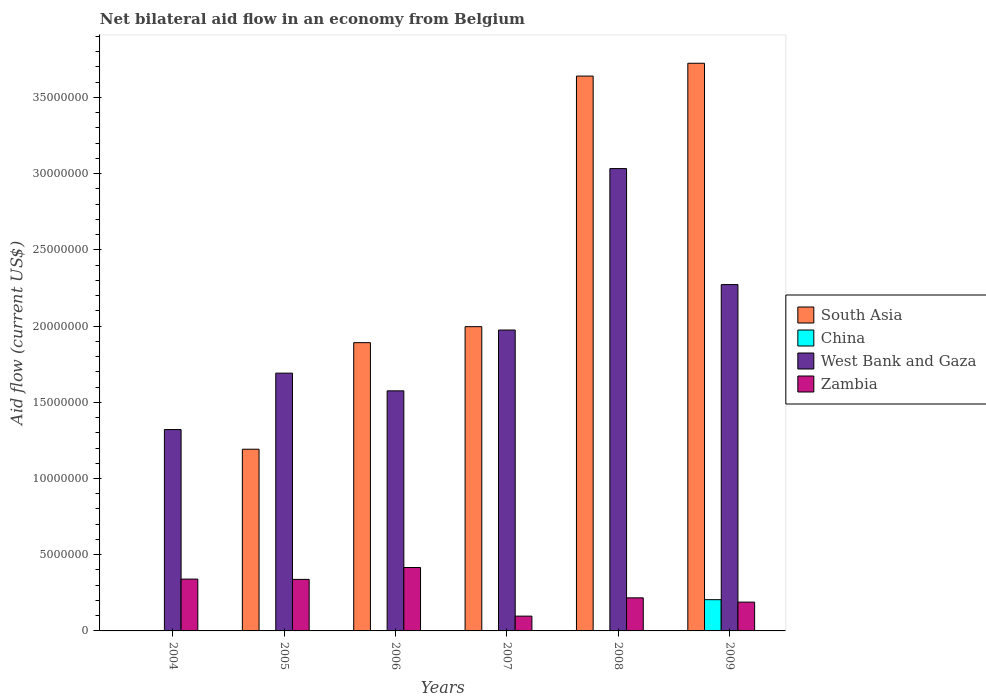In how many cases, is the number of bars for a given year not equal to the number of legend labels?
Give a very brief answer. 5. What is the net bilateral aid flow in West Bank and Gaza in 2005?
Offer a very short reply. 1.69e+07. Across all years, what is the maximum net bilateral aid flow in China?
Offer a very short reply. 2.05e+06. Across all years, what is the minimum net bilateral aid flow in West Bank and Gaza?
Offer a terse response. 1.32e+07. What is the total net bilateral aid flow in China in the graph?
Ensure brevity in your answer.  2.05e+06. What is the difference between the net bilateral aid flow in Zambia in 2006 and that in 2008?
Make the answer very short. 1.99e+06. What is the difference between the net bilateral aid flow in Zambia in 2005 and the net bilateral aid flow in South Asia in 2009?
Provide a succinct answer. -3.39e+07. What is the average net bilateral aid flow in South Asia per year?
Offer a terse response. 2.07e+07. In the year 2004, what is the difference between the net bilateral aid flow in West Bank and Gaza and net bilateral aid flow in Zambia?
Keep it short and to the point. 9.81e+06. What is the ratio of the net bilateral aid flow in West Bank and Gaza in 2004 to that in 2007?
Your answer should be compact. 0.67. What is the difference between the highest and the second highest net bilateral aid flow in West Bank and Gaza?
Ensure brevity in your answer.  7.61e+06. What is the difference between the highest and the lowest net bilateral aid flow in China?
Give a very brief answer. 2.05e+06. In how many years, is the net bilateral aid flow in South Asia greater than the average net bilateral aid flow in South Asia taken over all years?
Offer a terse response. 2. Is the sum of the net bilateral aid flow in West Bank and Gaza in 2006 and 2009 greater than the maximum net bilateral aid flow in South Asia across all years?
Keep it short and to the point. Yes. Is it the case that in every year, the sum of the net bilateral aid flow in China and net bilateral aid flow in West Bank and Gaza is greater than the sum of net bilateral aid flow in South Asia and net bilateral aid flow in Zambia?
Offer a terse response. Yes. Is it the case that in every year, the sum of the net bilateral aid flow in China and net bilateral aid flow in West Bank and Gaza is greater than the net bilateral aid flow in Zambia?
Give a very brief answer. Yes. How many bars are there?
Your answer should be very brief. 18. Are all the bars in the graph horizontal?
Offer a terse response. No. What is the difference between two consecutive major ticks on the Y-axis?
Provide a succinct answer. 5.00e+06. Are the values on the major ticks of Y-axis written in scientific E-notation?
Your response must be concise. No. Does the graph contain any zero values?
Offer a very short reply. Yes. How are the legend labels stacked?
Your response must be concise. Vertical. What is the title of the graph?
Your answer should be compact. Net bilateral aid flow in an economy from Belgium. Does "Turkey" appear as one of the legend labels in the graph?
Your response must be concise. No. What is the Aid flow (current US$) of West Bank and Gaza in 2004?
Provide a succinct answer. 1.32e+07. What is the Aid flow (current US$) of Zambia in 2004?
Give a very brief answer. 3.40e+06. What is the Aid flow (current US$) in South Asia in 2005?
Keep it short and to the point. 1.19e+07. What is the Aid flow (current US$) of West Bank and Gaza in 2005?
Your response must be concise. 1.69e+07. What is the Aid flow (current US$) in Zambia in 2005?
Provide a succinct answer. 3.38e+06. What is the Aid flow (current US$) of South Asia in 2006?
Provide a succinct answer. 1.89e+07. What is the Aid flow (current US$) of West Bank and Gaza in 2006?
Ensure brevity in your answer.  1.58e+07. What is the Aid flow (current US$) in Zambia in 2006?
Your answer should be compact. 4.16e+06. What is the Aid flow (current US$) in South Asia in 2007?
Your answer should be compact. 2.00e+07. What is the Aid flow (current US$) of West Bank and Gaza in 2007?
Offer a very short reply. 1.97e+07. What is the Aid flow (current US$) in Zambia in 2007?
Make the answer very short. 9.70e+05. What is the Aid flow (current US$) in South Asia in 2008?
Give a very brief answer. 3.64e+07. What is the Aid flow (current US$) of West Bank and Gaza in 2008?
Keep it short and to the point. 3.03e+07. What is the Aid flow (current US$) of Zambia in 2008?
Your answer should be very brief. 2.17e+06. What is the Aid flow (current US$) in South Asia in 2009?
Provide a short and direct response. 3.72e+07. What is the Aid flow (current US$) of China in 2009?
Your response must be concise. 2.05e+06. What is the Aid flow (current US$) of West Bank and Gaza in 2009?
Offer a very short reply. 2.27e+07. What is the Aid flow (current US$) of Zambia in 2009?
Ensure brevity in your answer.  1.89e+06. Across all years, what is the maximum Aid flow (current US$) in South Asia?
Your answer should be compact. 3.72e+07. Across all years, what is the maximum Aid flow (current US$) in China?
Your response must be concise. 2.05e+06. Across all years, what is the maximum Aid flow (current US$) in West Bank and Gaza?
Your answer should be very brief. 3.03e+07. Across all years, what is the maximum Aid flow (current US$) of Zambia?
Offer a very short reply. 4.16e+06. Across all years, what is the minimum Aid flow (current US$) of China?
Provide a succinct answer. 0. Across all years, what is the minimum Aid flow (current US$) in West Bank and Gaza?
Provide a short and direct response. 1.32e+07. Across all years, what is the minimum Aid flow (current US$) in Zambia?
Provide a short and direct response. 9.70e+05. What is the total Aid flow (current US$) in South Asia in the graph?
Keep it short and to the point. 1.24e+08. What is the total Aid flow (current US$) of China in the graph?
Offer a very short reply. 2.05e+06. What is the total Aid flow (current US$) in West Bank and Gaza in the graph?
Keep it short and to the point. 1.19e+08. What is the total Aid flow (current US$) in Zambia in the graph?
Ensure brevity in your answer.  1.60e+07. What is the difference between the Aid flow (current US$) of West Bank and Gaza in 2004 and that in 2005?
Your answer should be very brief. -3.70e+06. What is the difference between the Aid flow (current US$) of West Bank and Gaza in 2004 and that in 2006?
Offer a very short reply. -2.54e+06. What is the difference between the Aid flow (current US$) in Zambia in 2004 and that in 2006?
Provide a succinct answer. -7.60e+05. What is the difference between the Aid flow (current US$) of West Bank and Gaza in 2004 and that in 2007?
Ensure brevity in your answer.  -6.53e+06. What is the difference between the Aid flow (current US$) of Zambia in 2004 and that in 2007?
Provide a succinct answer. 2.43e+06. What is the difference between the Aid flow (current US$) in West Bank and Gaza in 2004 and that in 2008?
Provide a short and direct response. -1.71e+07. What is the difference between the Aid flow (current US$) in Zambia in 2004 and that in 2008?
Provide a short and direct response. 1.23e+06. What is the difference between the Aid flow (current US$) in West Bank and Gaza in 2004 and that in 2009?
Offer a terse response. -9.51e+06. What is the difference between the Aid flow (current US$) of Zambia in 2004 and that in 2009?
Offer a terse response. 1.51e+06. What is the difference between the Aid flow (current US$) of South Asia in 2005 and that in 2006?
Ensure brevity in your answer.  -6.99e+06. What is the difference between the Aid flow (current US$) of West Bank and Gaza in 2005 and that in 2006?
Your response must be concise. 1.16e+06. What is the difference between the Aid flow (current US$) of Zambia in 2005 and that in 2006?
Offer a very short reply. -7.80e+05. What is the difference between the Aid flow (current US$) of South Asia in 2005 and that in 2007?
Give a very brief answer. -8.04e+06. What is the difference between the Aid flow (current US$) in West Bank and Gaza in 2005 and that in 2007?
Provide a succinct answer. -2.83e+06. What is the difference between the Aid flow (current US$) in Zambia in 2005 and that in 2007?
Give a very brief answer. 2.41e+06. What is the difference between the Aid flow (current US$) in South Asia in 2005 and that in 2008?
Your response must be concise. -2.45e+07. What is the difference between the Aid flow (current US$) in West Bank and Gaza in 2005 and that in 2008?
Ensure brevity in your answer.  -1.34e+07. What is the difference between the Aid flow (current US$) in Zambia in 2005 and that in 2008?
Offer a terse response. 1.21e+06. What is the difference between the Aid flow (current US$) in South Asia in 2005 and that in 2009?
Provide a succinct answer. -2.53e+07. What is the difference between the Aid flow (current US$) of West Bank and Gaza in 2005 and that in 2009?
Provide a short and direct response. -5.81e+06. What is the difference between the Aid flow (current US$) in Zambia in 2005 and that in 2009?
Make the answer very short. 1.49e+06. What is the difference between the Aid flow (current US$) of South Asia in 2006 and that in 2007?
Ensure brevity in your answer.  -1.05e+06. What is the difference between the Aid flow (current US$) in West Bank and Gaza in 2006 and that in 2007?
Offer a terse response. -3.99e+06. What is the difference between the Aid flow (current US$) of Zambia in 2006 and that in 2007?
Your answer should be very brief. 3.19e+06. What is the difference between the Aid flow (current US$) in South Asia in 2006 and that in 2008?
Your answer should be compact. -1.75e+07. What is the difference between the Aid flow (current US$) of West Bank and Gaza in 2006 and that in 2008?
Keep it short and to the point. -1.46e+07. What is the difference between the Aid flow (current US$) in Zambia in 2006 and that in 2008?
Make the answer very short. 1.99e+06. What is the difference between the Aid flow (current US$) of South Asia in 2006 and that in 2009?
Provide a succinct answer. -1.83e+07. What is the difference between the Aid flow (current US$) in West Bank and Gaza in 2006 and that in 2009?
Keep it short and to the point. -6.97e+06. What is the difference between the Aid flow (current US$) of Zambia in 2006 and that in 2009?
Make the answer very short. 2.27e+06. What is the difference between the Aid flow (current US$) of South Asia in 2007 and that in 2008?
Keep it short and to the point. -1.64e+07. What is the difference between the Aid flow (current US$) of West Bank and Gaza in 2007 and that in 2008?
Provide a succinct answer. -1.06e+07. What is the difference between the Aid flow (current US$) in Zambia in 2007 and that in 2008?
Keep it short and to the point. -1.20e+06. What is the difference between the Aid flow (current US$) of South Asia in 2007 and that in 2009?
Offer a terse response. -1.73e+07. What is the difference between the Aid flow (current US$) in West Bank and Gaza in 2007 and that in 2009?
Give a very brief answer. -2.98e+06. What is the difference between the Aid flow (current US$) in Zambia in 2007 and that in 2009?
Keep it short and to the point. -9.20e+05. What is the difference between the Aid flow (current US$) in South Asia in 2008 and that in 2009?
Offer a very short reply. -8.40e+05. What is the difference between the Aid flow (current US$) in West Bank and Gaza in 2008 and that in 2009?
Keep it short and to the point. 7.61e+06. What is the difference between the Aid flow (current US$) in Zambia in 2008 and that in 2009?
Offer a very short reply. 2.80e+05. What is the difference between the Aid flow (current US$) of West Bank and Gaza in 2004 and the Aid flow (current US$) of Zambia in 2005?
Provide a succinct answer. 9.83e+06. What is the difference between the Aid flow (current US$) in West Bank and Gaza in 2004 and the Aid flow (current US$) in Zambia in 2006?
Give a very brief answer. 9.05e+06. What is the difference between the Aid flow (current US$) of West Bank and Gaza in 2004 and the Aid flow (current US$) of Zambia in 2007?
Your answer should be compact. 1.22e+07. What is the difference between the Aid flow (current US$) in West Bank and Gaza in 2004 and the Aid flow (current US$) in Zambia in 2008?
Make the answer very short. 1.10e+07. What is the difference between the Aid flow (current US$) in West Bank and Gaza in 2004 and the Aid flow (current US$) in Zambia in 2009?
Your answer should be very brief. 1.13e+07. What is the difference between the Aid flow (current US$) in South Asia in 2005 and the Aid flow (current US$) in West Bank and Gaza in 2006?
Your answer should be very brief. -3.83e+06. What is the difference between the Aid flow (current US$) of South Asia in 2005 and the Aid flow (current US$) of Zambia in 2006?
Make the answer very short. 7.76e+06. What is the difference between the Aid flow (current US$) of West Bank and Gaza in 2005 and the Aid flow (current US$) of Zambia in 2006?
Offer a very short reply. 1.28e+07. What is the difference between the Aid flow (current US$) in South Asia in 2005 and the Aid flow (current US$) in West Bank and Gaza in 2007?
Offer a very short reply. -7.82e+06. What is the difference between the Aid flow (current US$) in South Asia in 2005 and the Aid flow (current US$) in Zambia in 2007?
Your answer should be compact. 1.10e+07. What is the difference between the Aid flow (current US$) in West Bank and Gaza in 2005 and the Aid flow (current US$) in Zambia in 2007?
Give a very brief answer. 1.59e+07. What is the difference between the Aid flow (current US$) of South Asia in 2005 and the Aid flow (current US$) of West Bank and Gaza in 2008?
Your response must be concise. -1.84e+07. What is the difference between the Aid flow (current US$) in South Asia in 2005 and the Aid flow (current US$) in Zambia in 2008?
Your answer should be very brief. 9.75e+06. What is the difference between the Aid flow (current US$) in West Bank and Gaza in 2005 and the Aid flow (current US$) in Zambia in 2008?
Your answer should be very brief. 1.47e+07. What is the difference between the Aid flow (current US$) in South Asia in 2005 and the Aid flow (current US$) in China in 2009?
Provide a succinct answer. 9.87e+06. What is the difference between the Aid flow (current US$) of South Asia in 2005 and the Aid flow (current US$) of West Bank and Gaza in 2009?
Provide a succinct answer. -1.08e+07. What is the difference between the Aid flow (current US$) in South Asia in 2005 and the Aid flow (current US$) in Zambia in 2009?
Offer a very short reply. 1.00e+07. What is the difference between the Aid flow (current US$) in West Bank and Gaza in 2005 and the Aid flow (current US$) in Zambia in 2009?
Your answer should be compact. 1.50e+07. What is the difference between the Aid flow (current US$) in South Asia in 2006 and the Aid flow (current US$) in West Bank and Gaza in 2007?
Make the answer very short. -8.30e+05. What is the difference between the Aid flow (current US$) of South Asia in 2006 and the Aid flow (current US$) of Zambia in 2007?
Your answer should be very brief. 1.79e+07. What is the difference between the Aid flow (current US$) of West Bank and Gaza in 2006 and the Aid flow (current US$) of Zambia in 2007?
Provide a short and direct response. 1.48e+07. What is the difference between the Aid flow (current US$) in South Asia in 2006 and the Aid flow (current US$) in West Bank and Gaza in 2008?
Your response must be concise. -1.14e+07. What is the difference between the Aid flow (current US$) of South Asia in 2006 and the Aid flow (current US$) of Zambia in 2008?
Your answer should be compact. 1.67e+07. What is the difference between the Aid flow (current US$) in West Bank and Gaza in 2006 and the Aid flow (current US$) in Zambia in 2008?
Your response must be concise. 1.36e+07. What is the difference between the Aid flow (current US$) of South Asia in 2006 and the Aid flow (current US$) of China in 2009?
Offer a terse response. 1.69e+07. What is the difference between the Aid flow (current US$) of South Asia in 2006 and the Aid flow (current US$) of West Bank and Gaza in 2009?
Your response must be concise. -3.81e+06. What is the difference between the Aid flow (current US$) in South Asia in 2006 and the Aid flow (current US$) in Zambia in 2009?
Make the answer very short. 1.70e+07. What is the difference between the Aid flow (current US$) of West Bank and Gaza in 2006 and the Aid flow (current US$) of Zambia in 2009?
Your response must be concise. 1.39e+07. What is the difference between the Aid flow (current US$) in South Asia in 2007 and the Aid flow (current US$) in West Bank and Gaza in 2008?
Offer a terse response. -1.04e+07. What is the difference between the Aid flow (current US$) of South Asia in 2007 and the Aid flow (current US$) of Zambia in 2008?
Your answer should be compact. 1.78e+07. What is the difference between the Aid flow (current US$) of West Bank and Gaza in 2007 and the Aid flow (current US$) of Zambia in 2008?
Ensure brevity in your answer.  1.76e+07. What is the difference between the Aid flow (current US$) of South Asia in 2007 and the Aid flow (current US$) of China in 2009?
Provide a succinct answer. 1.79e+07. What is the difference between the Aid flow (current US$) in South Asia in 2007 and the Aid flow (current US$) in West Bank and Gaza in 2009?
Offer a very short reply. -2.76e+06. What is the difference between the Aid flow (current US$) in South Asia in 2007 and the Aid flow (current US$) in Zambia in 2009?
Offer a terse response. 1.81e+07. What is the difference between the Aid flow (current US$) of West Bank and Gaza in 2007 and the Aid flow (current US$) of Zambia in 2009?
Offer a very short reply. 1.78e+07. What is the difference between the Aid flow (current US$) of South Asia in 2008 and the Aid flow (current US$) of China in 2009?
Your answer should be compact. 3.44e+07. What is the difference between the Aid flow (current US$) in South Asia in 2008 and the Aid flow (current US$) in West Bank and Gaza in 2009?
Your response must be concise. 1.37e+07. What is the difference between the Aid flow (current US$) of South Asia in 2008 and the Aid flow (current US$) of Zambia in 2009?
Give a very brief answer. 3.45e+07. What is the difference between the Aid flow (current US$) in West Bank and Gaza in 2008 and the Aid flow (current US$) in Zambia in 2009?
Offer a terse response. 2.84e+07. What is the average Aid flow (current US$) in South Asia per year?
Offer a terse response. 2.07e+07. What is the average Aid flow (current US$) of China per year?
Your response must be concise. 3.42e+05. What is the average Aid flow (current US$) in West Bank and Gaza per year?
Offer a terse response. 1.98e+07. What is the average Aid flow (current US$) in Zambia per year?
Your answer should be very brief. 2.66e+06. In the year 2004, what is the difference between the Aid flow (current US$) of West Bank and Gaza and Aid flow (current US$) of Zambia?
Your answer should be very brief. 9.81e+06. In the year 2005, what is the difference between the Aid flow (current US$) of South Asia and Aid flow (current US$) of West Bank and Gaza?
Provide a succinct answer. -4.99e+06. In the year 2005, what is the difference between the Aid flow (current US$) in South Asia and Aid flow (current US$) in Zambia?
Keep it short and to the point. 8.54e+06. In the year 2005, what is the difference between the Aid flow (current US$) in West Bank and Gaza and Aid flow (current US$) in Zambia?
Offer a terse response. 1.35e+07. In the year 2006, what is the difference between the Aid flow (current US$) in South Asia and Aid flow (current US$) in West Bank and Gaza?
Ensure brevity in your answer.  3.16e+06. In the year 2006, what is the difference between the Aid flow (current US$) of South Asia and Aid flow (current US$) of Zambia?
Your answer should be compact. 1.48e+07. In the year 2006, what is the difference between the Aid flow (current US$) in West Bank and Gaza and Aid flow (current US$) in Zambia?
Provide a succinct answer. 1.16e+07. In the year 2007, what is the difference between the Aid flow (current US$) in South Asia and Aid flow (current US$) in Zambia?
Give a very brief answer. 1.90e+07. In the year 2007, what is the difference between the Aid flow (current US$) of West Bank and Gaza and Aid flow (current US$) of Zambia?
Your answer should be compact. 1.88e+07. In the year 2008, what is the difference between the Aid flow (current US$) of South Asia and Aid flow (current US$) of West Bank and Gaza?
Offer a terse response. 6.07e+06. In the year 2008, what is the difference between the Aid flow (current US$) in South Asia and Aid flow (current US$) in Zambia?
Your response must be concise. 3.42e+07. In the year 2008, what is the difference between the Aid flow (current US$) of West Bank and Gaza and Aid flow (current US$) of Zambia?
Keep it short and to the point. 2.82e+07. In the year 2009, what is the difference between the Aid flow (current US$) in South Asia and Aid flow (current US$) in China?
Keep it short and to the point. 3.52e+07. In the year 2009, what is the difference between the Aid flow (current US$) in South Asia and Aid flow (current US$) in West Bank and Gaza?
Keep it short and to the point. 1.45e+07. In the year 2009, what is the difference between the Aid flow (current US$) in South Asia and Aid flow (current US$) in Zambia?
Provide a short and direct response. 3.54e+07. In the year 2009, what is the difference between the Aid flow (current US$) in China and Aid flow (current US$) in West Bank and Gaza?
Your answer should be very brief. -2.07e+07. In the year 2009, what is the difference between the Aid flow (current US$) of China and Aid flow (current US$) of Zambia?
Your response must be concise. 1.60e+05. In the year 2009, what is the difference between the Aid flow (current US$) in West Bank and Gaza and Aid flow (current US$) in Zambia?
Your answer should be compact. 2.08e+07. What is the ratio of the Aid flow (current US$) in West Bank and Gaza in 2004 to that in 2005?
Provide a short and direct response. 0.78. What is the ratio of the Aid flow (current US$) in Zambia in 2004 to that in 2005?
Your answer should be compact. 1.01. What is the ratio of the Aid flow (current US$) of West Bank and Gaza in 2004 to that in 2006?
Your response must be concise. 0.84. What is the ratio of the Aid flow (current US$) of Zambia in 2004 to that in 2006?
Your response must be concise. 0.82. What is the ratio of the Aid flow (current US$) in West Bank and Gaza in 2004 to that in 2007?
Keep it short and to the point. 0.67. What is the ratio of the Aid flow (current US$) of Zambia in 2004 to that in 2007?
Keep it short and to the point. 3.51. What is the ratio of the Aid flow (current US$) in West Bank and Gaza in 2004 to that in 2008?
Provide a short and direct response. 0.44. What is the ratio of the Aid flow (current US$) of Zambia in 2004 to that in 2008?
Keep it short and to the point. 1.57. What is the ratio of the Aid flow (current US$) of West Bank and Gaza in 2004 to that in 2009?
Provide a short and direct response. 0.58. What is the ratio of the Aid flow (current US$) of Zambia in 2004 to that in 2009?
Make the answer very short. 1.8. What is the ratio of the Aid flow (current US$) in South Asia in 2005 to that in 2006?
Make the answer very short. 0.63. What is the ratio of the Aid flow (current US$) of West Bank and Gaza in 2005 to that in 2006?
Make the answer very short. 1.07. What is the ratio of the Aid flow (current US$) of Zambia in 2005 to that in 2006?
Offer a very short reply. 0.81. What is the ratio of the Aid flow (current US$) of South Asia in 2005 to that in 2007?
Give a very brief answer. 0.6. What is the ratio of the Aid flow (current US$) in West Bank and Gaza in 2005 to that in 2007?
Your response must be concise. 0.86. What is the ratio of the Aid flow (current US$) of Zambia in 2005 to that in 2007?
Provide a short and direct response. 3.48. What is the ratio of the Aid flow (current US$) of South Asia in 2005 to that in 2008?
Make the answer very short. 0.33. What is the ratio of the Aid flow (current US$) of West Bank and Gaza in 2005 to that in 2008?
Ensure brevity in your answer.  0.56. What is the ratio of the Aid flow (current US$) of Zambia in 2005 to that in 2008?
Give a very brief answer. 1.56. What is the ratio of the Aid flow (current US$) in South Asia in 2005 to that in 2009?
Keep it short and to the point. 0.32. What is the ratio of the Aid flow (current US$) in West Bank and Gaza in 2005 to that in 2009?
Your answer should be very brief. 0.74. What is the ratio of the Aid flow (current US$) in Zambia in 2005 to that in 2009?
Your answer should be compact. 1.79. What is the ratio of the Aid flow (current US$) of South Asia in 2006 to that in 2007?
Your response must be concise. 0.95. What is the ratio of the Aid flow (current US$) of West Bank and Gaza in 2006 to that in 2007?
Your answer should be compact. 0.8. What is the ratio of the Aid flow (current US$) of Zambia in 2006 to that in 2007?
Keep it short and to the point. 4.29. What is the ratio of the Aid flow (current US$) of South Asia in 2006 to that in 2008?
Provide a succinct answer. 0.52. What is the ratio of the Aid flow (current US$) in West Bank and Gaza in 2006 to that in 2008?
Your answer should be compact. 0.52. What is the ratio of the Aid flow (current US$) in Zambia in 2006 to that in 2008?
Your response must be concise. 1.92. What is the ratio of the Aid flow (current US$) of South Asia in 2006 to that in 2009?
Offer a terse response. 0.51. What is the ratio of the Aid flow (current US$) in West Bank and Gaza in 2006 to that in 2009?
Ensure brevity in your answer.  0.69. What is the ratio of the Aid flow (current US$) of Zambia in 2006 to that in 2009?
Make the answer very short. 2.2. What is the ratio of the Aid flow (current US$) of South Asia in 2007 to that in 2008?
Make the answer very short. 0.55. What is the ratio of the Aid flow (current US$) in West Bank and Gaza in 2007 to that in 2008?
Your answer should be compact. 0.65. What is the ratio of the Aid flow (current US$) of Zambia in 2007 to that in 2008?
Keep it short and to the point. 0.45. What is the ratio of the Aid flow (current US$) of South Asia in 2007 to that in 2009?
Ensure brevity in your answer.  0.54. What is the ratio of the Aid flow (current US$) in West Bank and Gaza in 2007 to that in 2009?
Your response must be concise. 0.87. What is the ratio of the Aid flow (current US$) of Zambia in 2007 to that in 2009?
Offer a terse response. 0.51. What is the ratio of the Aid flow (current US$) of South Asia in 2008 to that in 2009?
Your response must be concise. 0.98. What is the ratio of the Aid flow (current US$) in West Bank and Gaza in 2008 to that in 2009?
Give a very brief answer. 1.33. What is the ratio of the Aid flow (current US$) of Zambia in 2008 to that in 2009?
Keep it short and to the point. 1.15. What is the difference between the highest and the second highest Aid flow (current US$) in South Asia?
Your answer should be compact. 8.40e+05. What is the difference between the highest and the second highest Aid flow (current US$) of West Bank and Gaza?
Make the answer very short. 7.61e+06. What is the difference between the highest and the second highest Aid flow (current US$) of Zambia?
Offer a terse response. 7.60e+05. What is the difference between the highest and the lowest Aid flow (current US$) of South Asia?
Make the answer very short. 3.72e+07. What is the difference between the highest and the lowest Aid flow (current US$) in China?
Keep it short and to the point. 2.05e+06. What is the difference between the highest and the lowest Aid flow (current US$) of West Bank and Gaza?
Offer a terse response. 1.71e+07. What is the difference between the highest and the lowest Aid flow (current US$) in Zambia?
Offer a very short reply. 3.19e+06. 